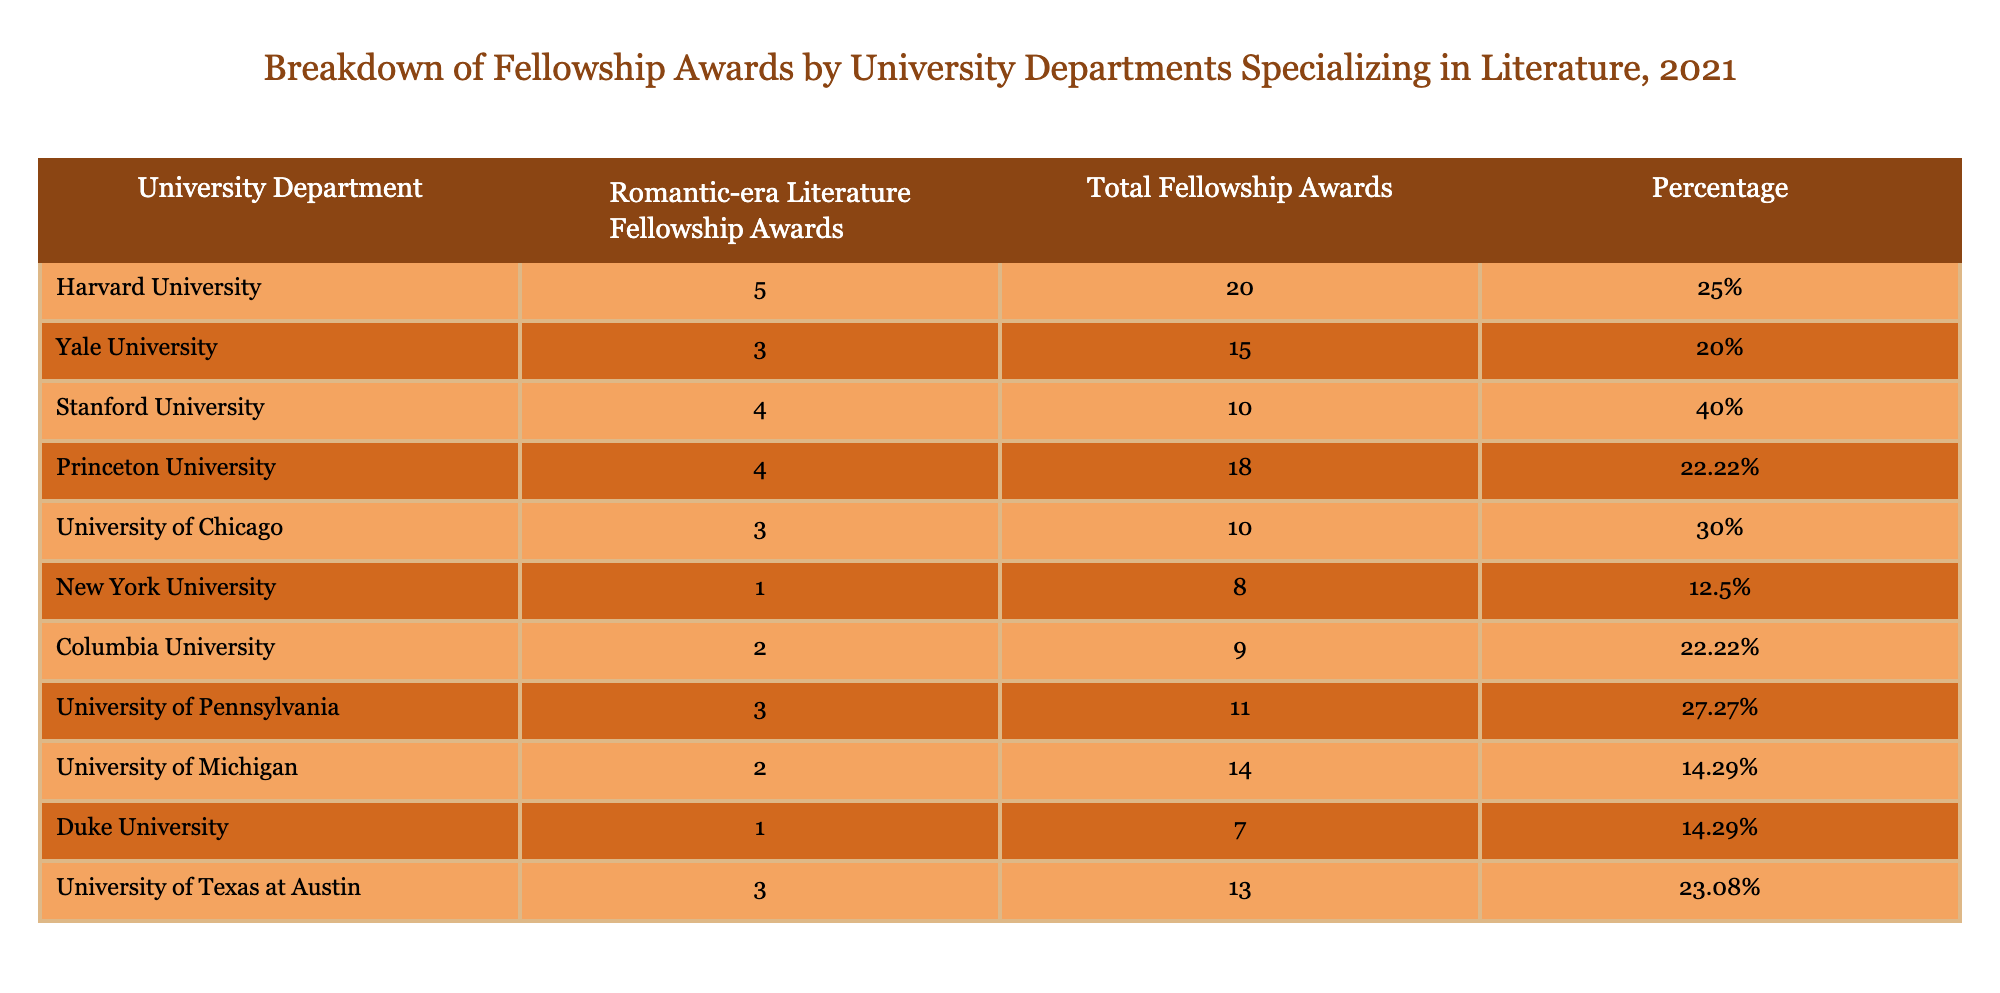What university department received the highest number of Romantic-era Literature Fellowship Awards? Looking at the first column, Harvard University has 5 awards, which is higher than any other department listed.
Answer: Harvard University What percentage of total fellowship awards did Stanford University receive? According to the table, Stanford University received 40% of its total fellowship awards, which is shown in the percentage column next to its number of awards.
Answer: 40% Which university department had the lowest total fellowship awards? By examining the total fellowship awards column, New York University has the lowest with a total of 8 awards.
Answer: New York University What is the average percentage of Romantic-era Literature Fellowship Awards across all departments? First, I sum up the percentages: 25% + 20% + 40% + 22.22% + 30% + 12.5% + 22.22% + 27.27% + 14.29% + 14.29% + 23.08% =  252.57%. There are 11 departments, so the average percentage is 252.57% / 11 which equals approximately 22.95%.
Answer: 22.95% Did the University of Pennsylvania receive more or fewer Romantic-era Literature Fellowship Awards than Columbia University? The University of Pennsylvania received 3 awards, while Columbia University received 2. Since 3 is greater than 2, the University of Pennsylvania received more awards.
Answer: More Which university received exactly 4 Romantic-era Literature Fellowship Awards? By scanning the number of awards column, both Stanford University and Princeton University have received exactly 4 awards.
Answer: Stanford University and Princeton University What is the total number of Romantic-era Literature Fellowship Awards given across all listed university departments? To find the total, add all the Romantic-era Literature Fellowship Awards from each department: 5 + 3 + 4 + 4 + 3 + 1 + 2 + 3 + 2 + 1 + 3 = 31.
Answer: 31 Is there any university department that received exactly 1 Romantic-era Literature Fellowship Award? A review of the fellowship awards indicates that New York University and Duke University each received 1 award. Thus, the answer is yes, there are departments with exactly 1 award.
Answer: Yes Which university department has a higher proportion of Romantic-era Literature Fellowship Awards relative to its total fellowship awards: University of Pennsylvania or University of Michigan? The University of Pennsylvania has 27.27% of its total awards as Romantic-era Literature fellowship (3 out of 11), while the University of Michigan has 14.29% (2 out of 14). Since 27.27% is greater than 14.29%, the University of Pennsylvania has a higher proportion.
Answer: University of Pennsylvania 